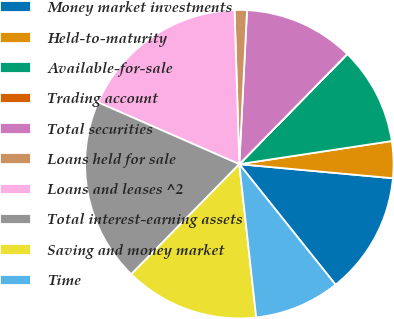Convert chart. <chart><loc_0><loc_0><loc_500><loc_500><pie_chart><fcel>Money market investments<fcel>Held-to-maturity<fcel>Available-for-sale<fcel>Trading account<fcel>Total securities<fcel>Loans held for sale<fcel>Loans and leases ^2<fcel>Total interest-earning assets<fcel>Saving and money market<fcel>Time<nl><fcel>12.82%<fcel>3.85%<fcel>10.26%<fcel>0.01%<fcel>11.54%<fcel>1.29%<fcel>17.94%<fcel>19.22%<fcel>14.1%<fcel>8.98%<nl></chart> 